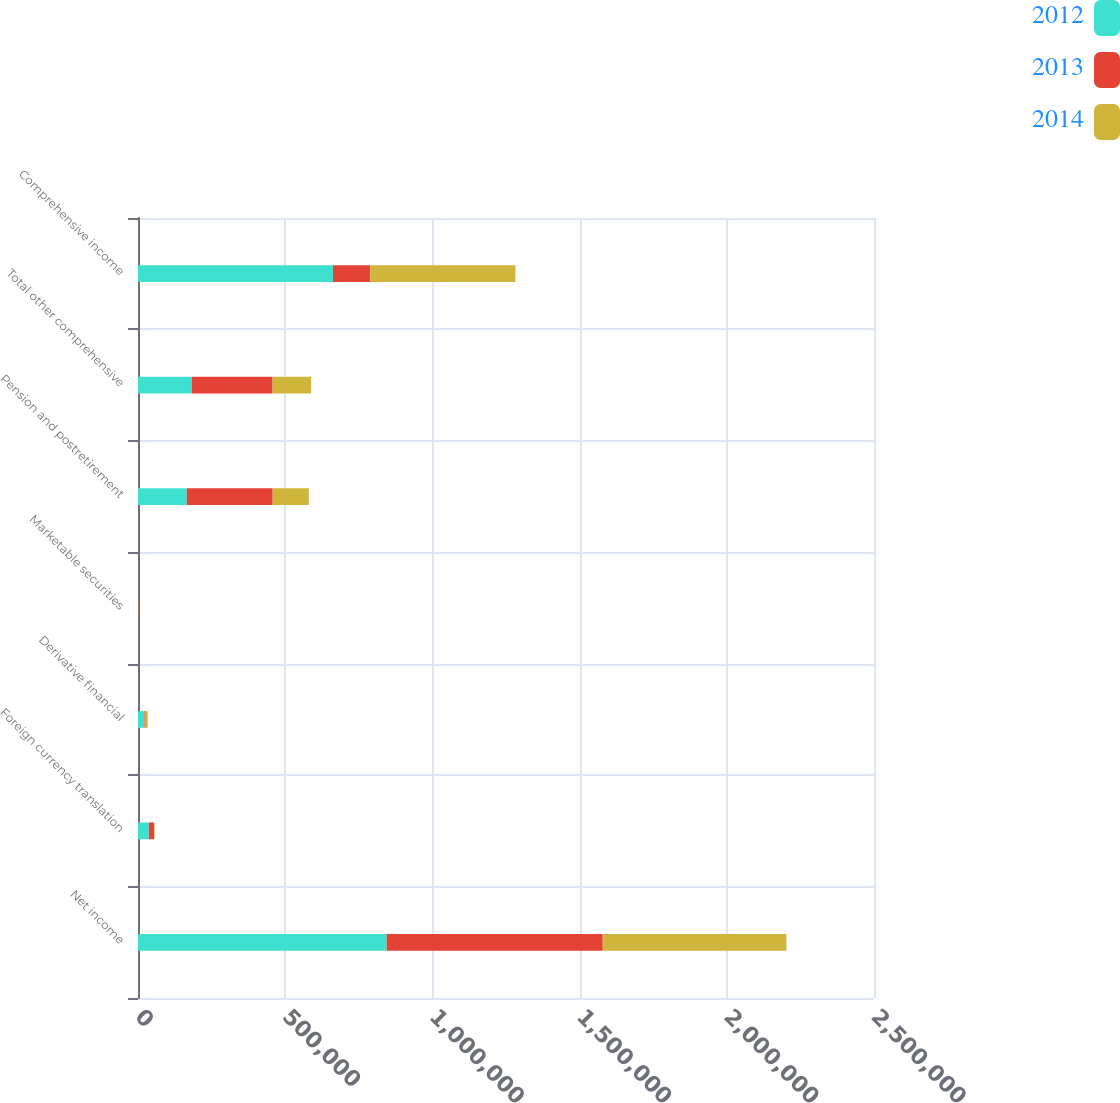<chart> <loc_0><loc_0><loc_500><loc_500><stacked_bar_chart><ecel><fcel>Net income<fcel>Foreign currency translation<fcel>Derivative financial<fcel>Marketable securities<fcel>Pension and postretirement<fcel>Total other comprehensive<fcel>Comprehensive income<nl><fcel>2012<fcel>844611<fcel>36808<fcel>20722<fcel>424<fcel>165757<fcel>182267<fcel>662344<nl><fcel>2013<fcel>733993<fcel>18009<fcel>2157<fcel>953<fcel>291807<fcel>275002<fcel>126748<nl><fcel>2014<fcel>623925<fcel>1400<fcel>10144<fcel>350<fcel>122551<fcel>130945<fcel>492980<nl></chart> 